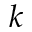<formula> <loc_0><loc_0><loc_500><loc_500>k</formula> 